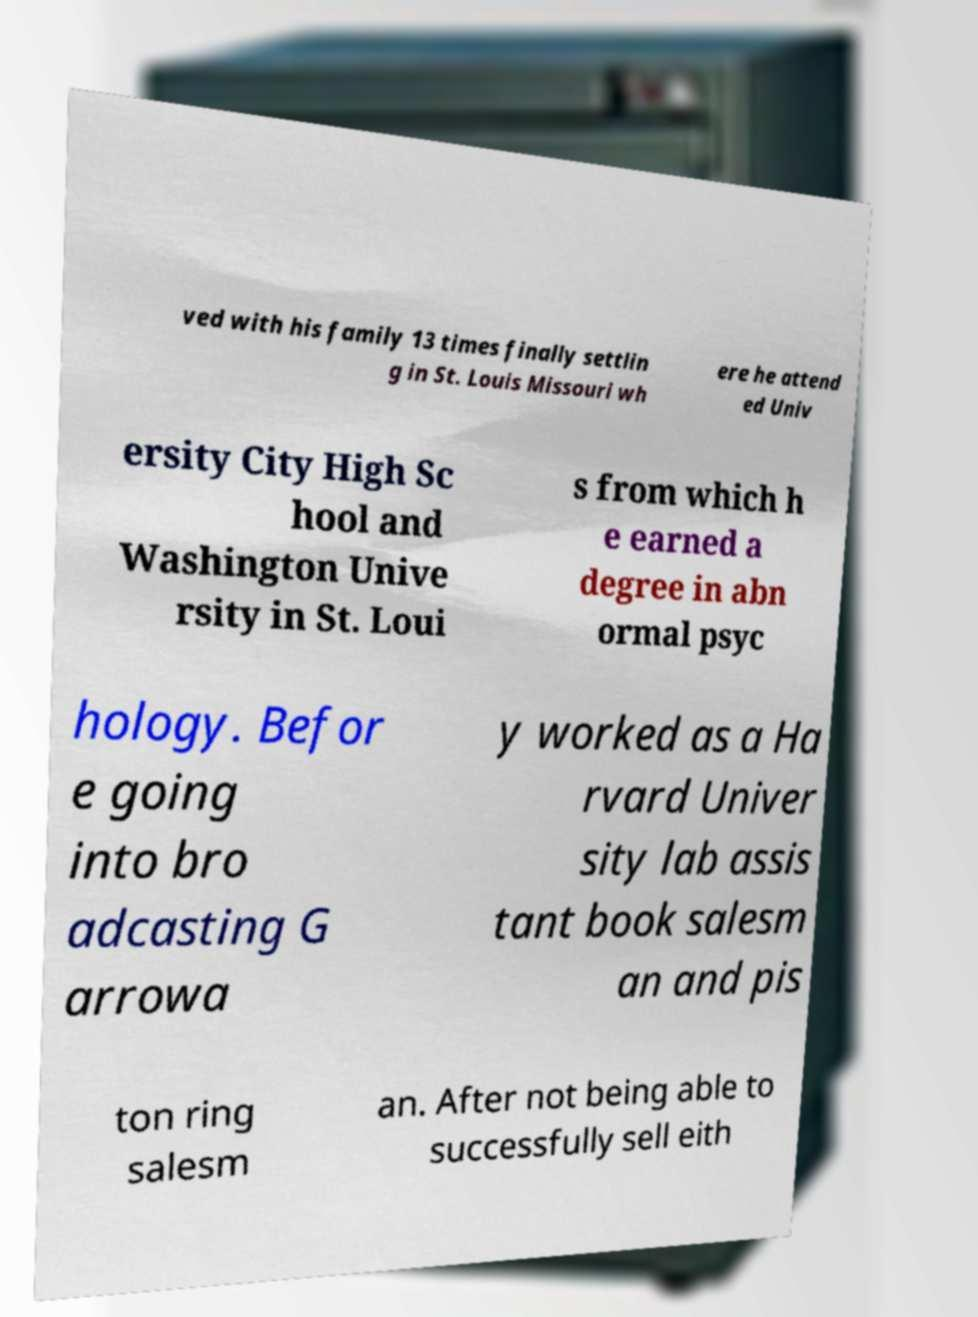Please read and relay the text visible in this image. What does it say? ved with his family 13 times finally settlin g in St. Louis Missouri wh ere he attend ed Univ ersity City High Sc hool and Washington Unive rsity in St. Loui s from which h e earned a degree in abn ormal psyc hology. Befor e going into bro adcasting G arrowa y worked as a Ha rvard Univer sity lab assis tant book salesm an and pis ton ring salesm an. After not being able to successfully sell eith 